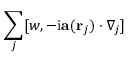Convert formula to latex. <formula><loc_0><loc_0><loc_500><loc_500>\sum _ { j } [ w , - i a ( r _ { j } ) \cdot \nabla _ { j } ]</formula> 